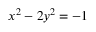Convert formula to latex. <formula><loc_0><loc_0><loc_500><loc_500>x ^ { 2 } - 2 y ^ { 2 } = - 1</formula> 